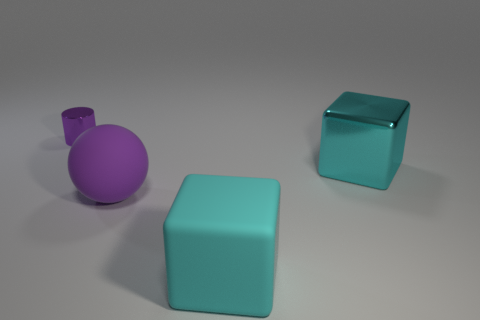Add 2 gray rubber cylinders. How many objects exist? 6 Subtract all cylinders. How many objects are left? 3 Add 2 big shiny things. How many big shiny things are left? 3 Add 1 large purple things. How many large purple things exist? 2 Subtract 0 blue cylinders. How many objects are left? 4 Subtract all large spheres. Subtract all small purple metal cylinders. How many objects are left? 2 